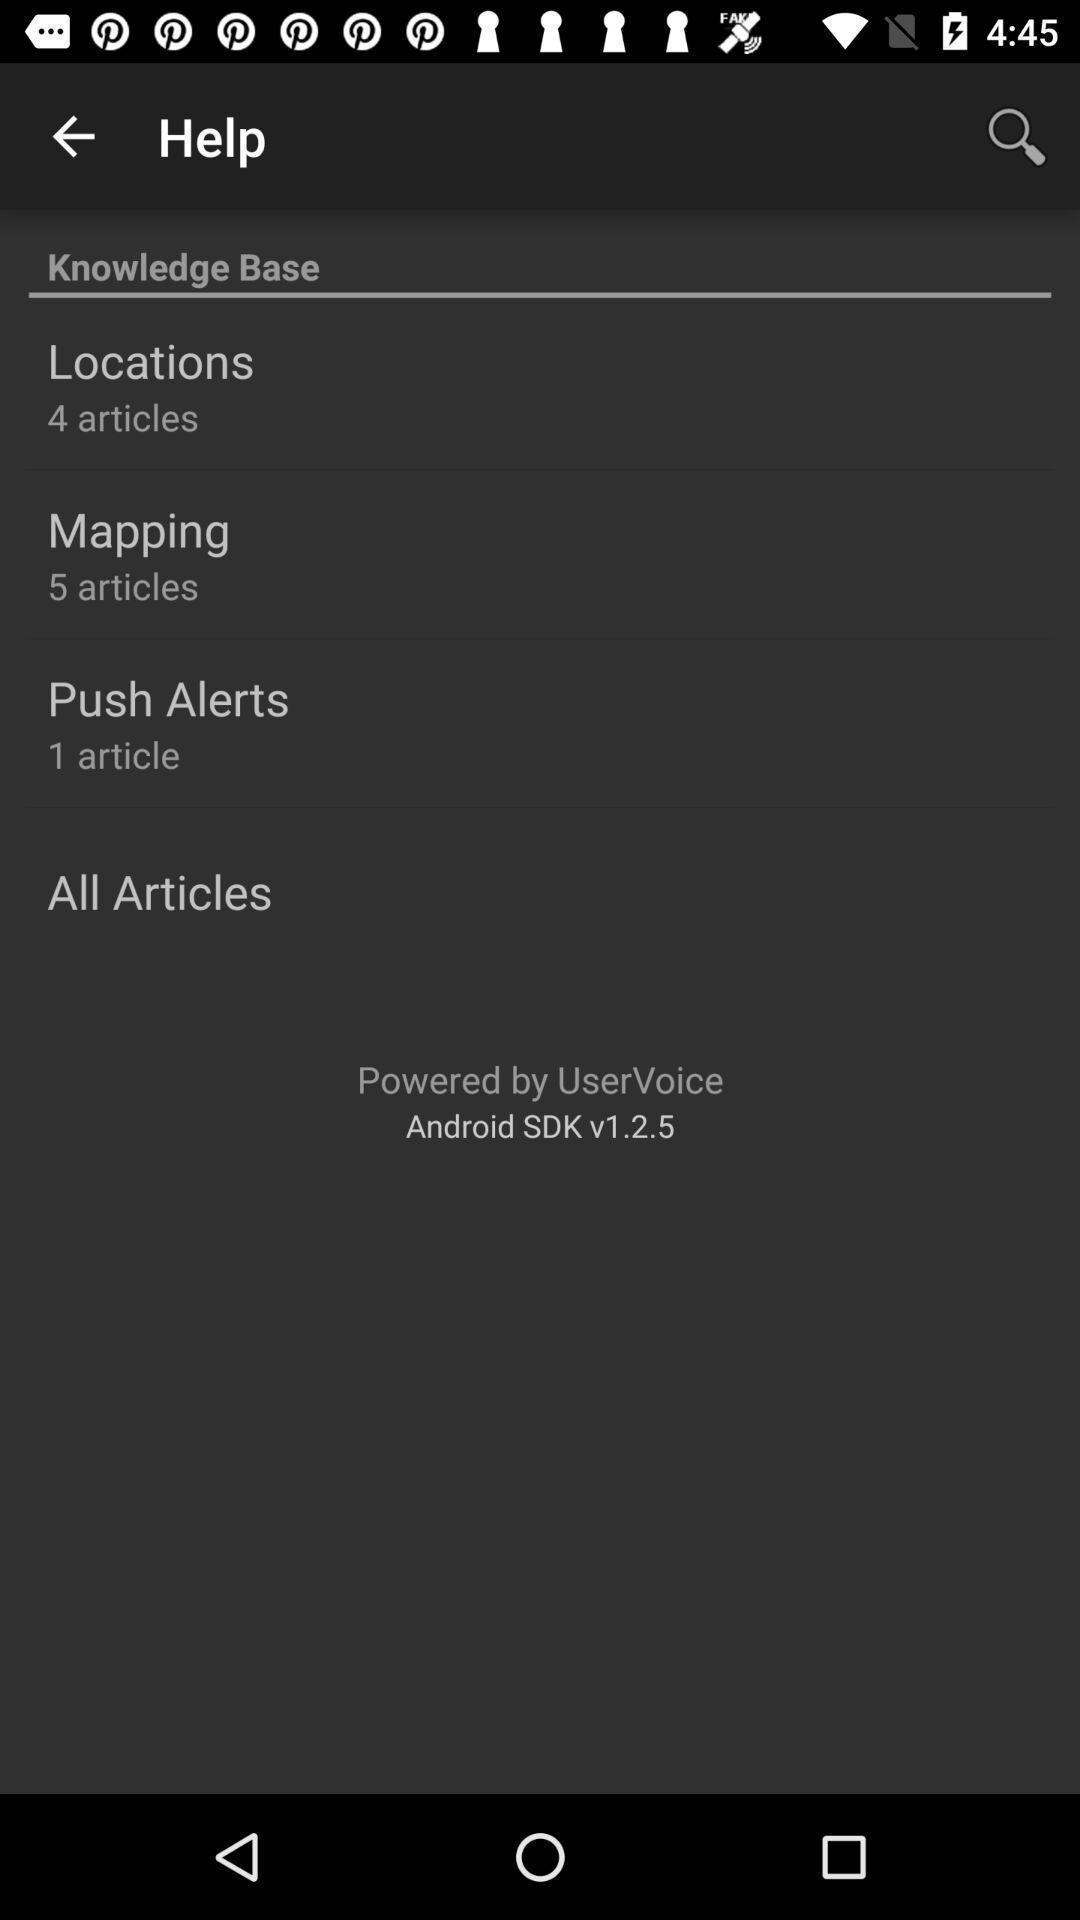Describe the content in this image. Screen shows help options. 